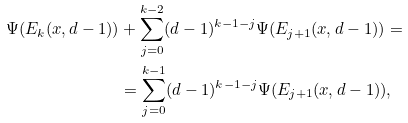<formula> <loc_0><loc_0><loc_500><loc_500>\Psi ( E _ { k } ( x , d - 1 ) ) & + \sum _ { j = 0 } ^ { k - 2 } ( d - 1 ) ^ { k - 1 - j } \Psi ( E _ { j + 1 } ( x , d - 1 ) ) = \\ & = \sum _ { j = 0 } ^ { k - 1 } ( d - 1 ) ^ { k - 1 - j } \Psi ( E _ { j + 1 } ( x , d - 1 ) ) ,</formula> 